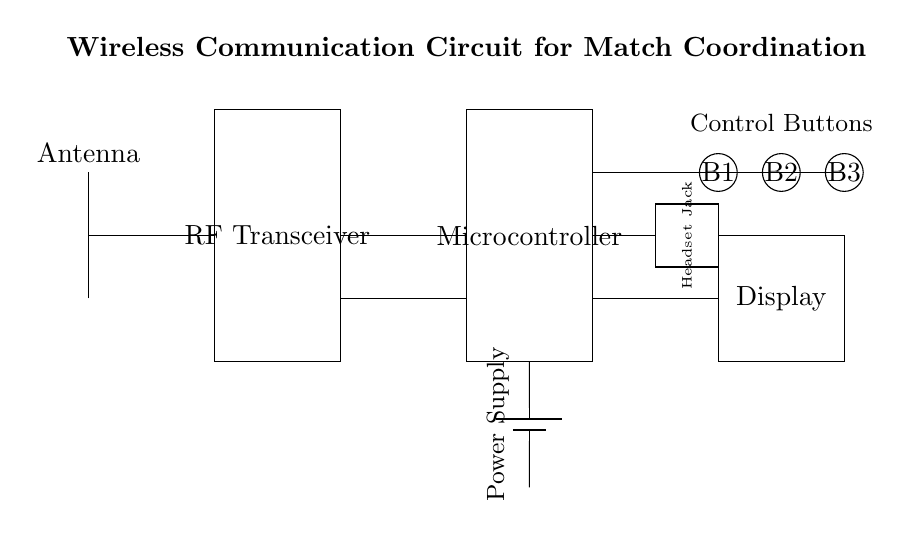What component initiates communication in this circuit? The component that initiates communication is the antenna, which is responsible for sending and receiving signals wirelessly. It is drawn at the top of the circuit diagram.
Answer: Antenna How many control buttons are there in this circuit? There are three control buttons, as indicated by the labeled circles (B1, B2, B3) drawn in a row in the circuit diagram.
Answer: Three What is the main function of the RF transceiver in this circuit? The RF transceiver's main function is to facilitate wireless communication by transmitting and receiving radio frequency signals. It is centrally located in the diagram.
Answer: Communication What does the microcontroller do in this circuit? The microcontroller processes signals and commands from the control buttons and communicates with the RF transceiver for coordination during matches. It acts as the brain of the circuit.
Answer: Process signals Which part of the circuit provides power? The part providing power is the battery, which is situated at the bottom of the diagram and connected to the other components, ensuring they operate with sufficient energy.
Answer: Battery Why is there a display included in this circuit? The display allows users to view important information or statuses related to the wireless communication, such as connection status or instructions, which is essential during matches.
Answer: User interface What is the purpose of the headset jack? The headset jack enables communication between the coach and players through headsets, allowing for discreet instructions during matches. It is represented in the circuit as a rectangle connected to the microcontroller.
Answer: Communication 